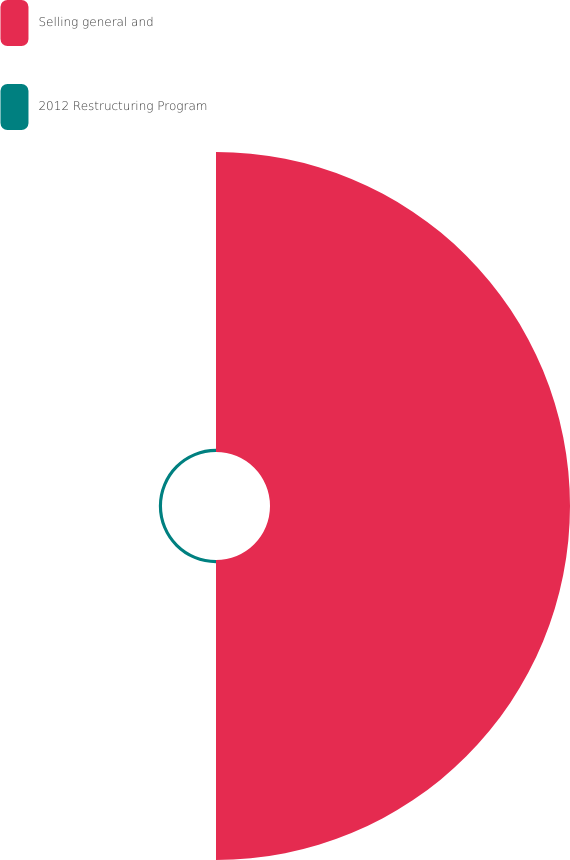Convert chart. <chart><loc_0><loc_0><loc_500><loc_500><pie_chart><fcel>Selling general and<fcel>2012 Restructuring Program<nl><fcel>98.96%<fcel>1.04%<nl></chart> 